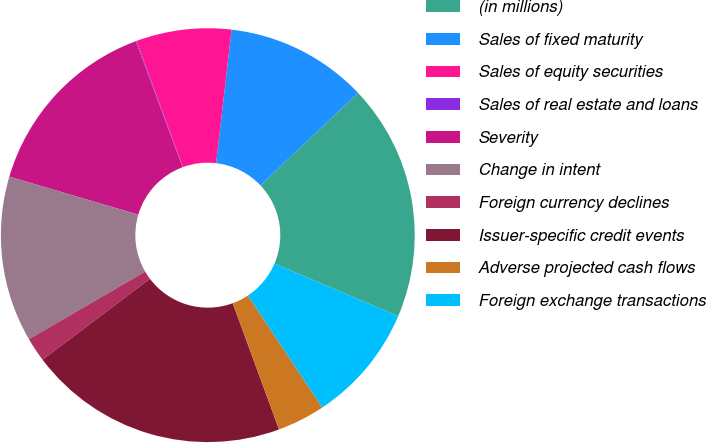Convert chart. <chart><loc_0><loc_0><loc_500><loc_500><pie_chart><fcel>(in millions)<fcel>Sales of fixed maturity<fcel>Sales of equity securities<fcel>Sales of real estate and loans<fcel>Severity<fcel>Change in intent<fcel>Foreign currency declines<fcel>Issuer-specific credit events<fcel>Adverse projected cash flows<fcel>Foreign exchange transactions<nl><fcel>18.46%<fcel>11.1%<fcel>7.42%<fcel>0.06%<fcel>14.78%<fcel>12.94%<fcel>1.9%<fcel>20.3%<fcel>3.74%<fcel>9.26%<nl></chart> 